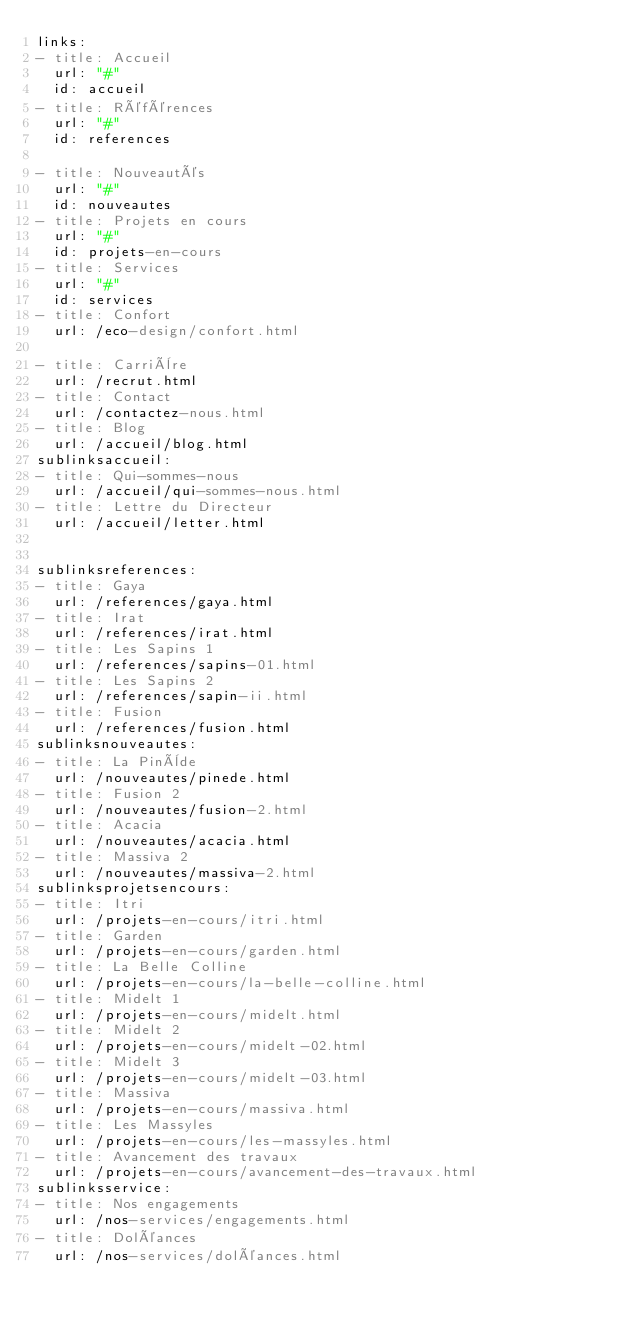<code> <loc_0><loc_0><loc_500><loc_500><_YAML_>links:
- title: Accueil
  url: "#"
  id: accueil
- title: Références
  url: "#"
  id: references

- title: Nouveautés
  url: "#"
  id: nouveautes
- title: Projets en cours
  url: "#"
  id: projets-en-cours
- title: Services
  url: "#"
  id: services
- title: Confort
  url: /eco-design/confort.html
  
- title: Carrière
  url: /recrut.html
- title: Contact
  url: /contactez-nous.html
- title: Blog
  url: /accueil/blog.html  
sublinksaccueil:
- title: Qui-sommes-nous
  url: /accueil/qui-sommes-nous.html
- title: Lettre du Directeur
  url: /accueil/letter.html


sublinksreferences:
- title: Gaya
  url: /references/gaya.html
- title: Irat
  url: /references/irat.html
- title: Les Sapins 1
  url: /references/sapins-01.html
- title: Les Sapins 2
  url: /references/sapin-ii.html
- title: Fusion
  url: /references/fusion.html  
sublinksnouveautes:
- title: La Pinède
  url: /nouveautes/pinede.html  
- title: Fusion 2
  url: /nouveautes/fusion-2.html    
- title: Acacia
  url: /nouveautes/acacia.html  
- title: Massiva 2
  url: /nouveautes/massiva-2.html    
sublinksprojetsencours:
- title: Itri
  url: /projets-en-cours/itri.html  
- title: Garden
  url: /projets-en-cours/garden.html
- title: La Belle Colline
  url: /projets-en-cours/la-belle-colline.html
- title: Midelt 1
  url: /projets-en-cours/midelt.html
- title: Midelt 2
  url: /projets-en-cours/midelt-02.html
- title: Midelt 3
  url: /projets-en-cours/midelt-03.html
- title: Massiva
  url: /projets-en-cours/massiva.html
- title: Les Massyles
  url: /projets-en-cours/les-massyles.html
- title: Avancement des travaux
  url: /projets-en-cours/avancement-des-travaux.html
sublinksservice:
- title: Nos engagements
  url: /nos-services/engagements.html
- title: Doléances
  url: /nos-services/doléances.html
</code> 